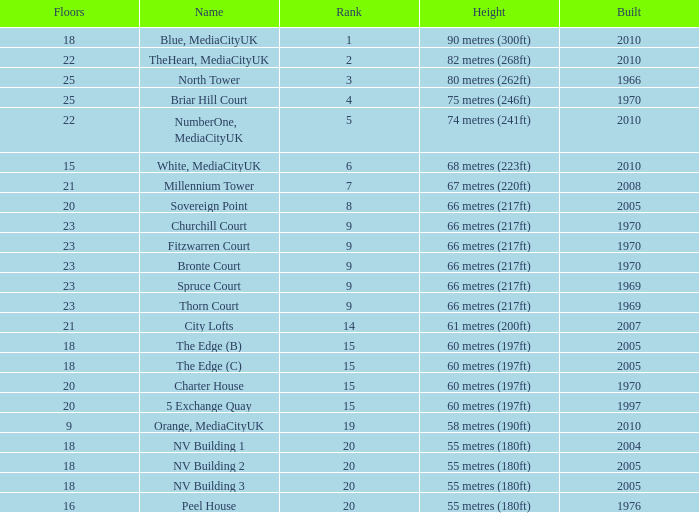What is the lowest Floors, when Built is greater than 1970, and when Name is NV Building 3? 18.0. 